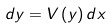Convert formula to latex. <formula><loc_0><loc_0><loc_500><loc_500>d y = V \left ( y \right ) d x</formula> 